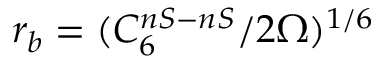<formula> <loc_0><loc_0><loc_500><loc_500>r _ { b } = ( C _ { 6 } ^ { n S - n S } / 2 \Omega ) ^ { 1 / 6 }</formula> 